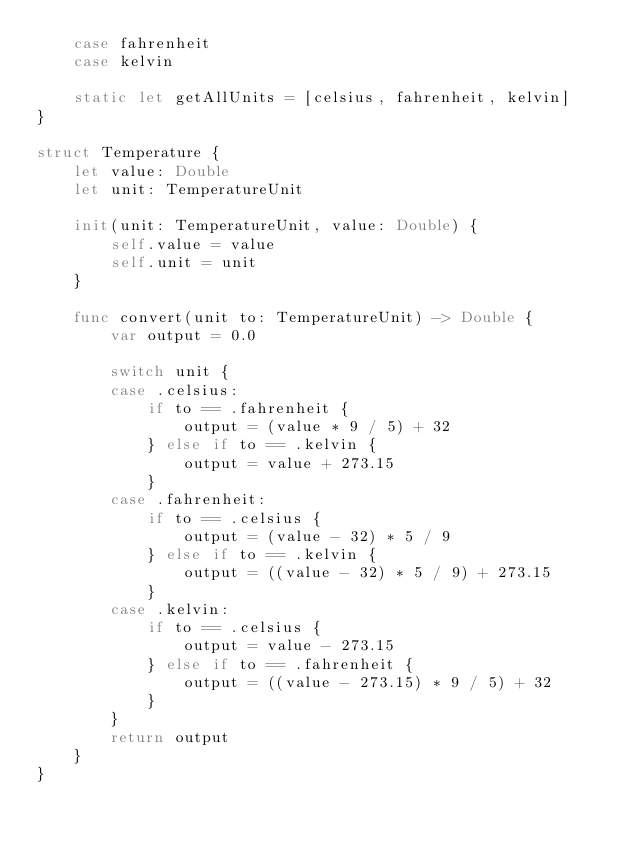Convert code to text. <code><loc_0><loc_0><loc_500><loc_500><_Swift_>    case fahrenheit
    case kelvin
    
    static let getAllUnits = [celsius, fahrenheit, kelvin]
}

struct Temperature {
    let value: Double
    let unit: TemperatureUnit
    
    init(unit: TemperatureUnit, value: Double) {
        self.value = value
        self.unit = unit
    }
    
    func convert(unit to: TemperatureUnit) -> Double {
        var output = 0.0
        
        switch unit {
        case .celsius:
            if to == .fahrenheit {
                output = (value * 9 / 5) + 32
            } else if to == .kelvin {
                output = value + 273.15
            }
        case .fahrenheit:
            if to == .celsius {
                output = (value - 32) * 5 / 9
            } else if to == .kelvin {
                output = ((value - 32) * 5 / 9) + 273.15
            }
        case .kelvin:
            if to == .celsius {
                output = value - 273.15
            } else if to == .fahrenheit {
                output = ((value - 273.15) * 9 / 5) + 32
            }
        }
        return output
    }
}
</code> 